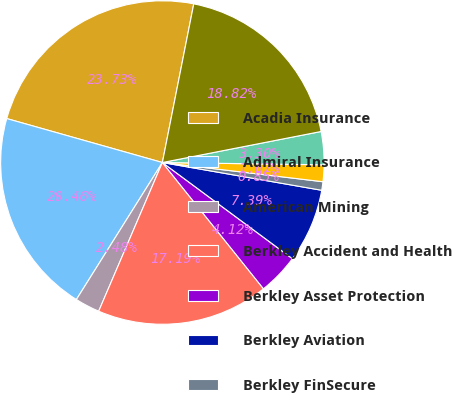Convert chart to OTSL. <chart><loc_0><loc_0><loc_500><loc_500><pie_chart><fcel>Acadia Insurance<fcel>Admiral Insurance<fcel>American Mining<fcel>Berkley Accident and Health<fcel>Berkley Asset Protection<fcel>Berkley Aviation<fcel>Berkley FinSecure<fcel>Berkley Life Sciences<fcel>Berkley Medical Excess<fcel>Berkley Mid-Atlantic Group<nl><fcel>23.73%<fcel>20.46%<fcel>2.48%<fcel>17.19%<fcel>4.12%<fcel>7.39%<fcel>0.85%<fcel>1.67%<fcel>3.3%<fcel>18.82%<nl></chart> 